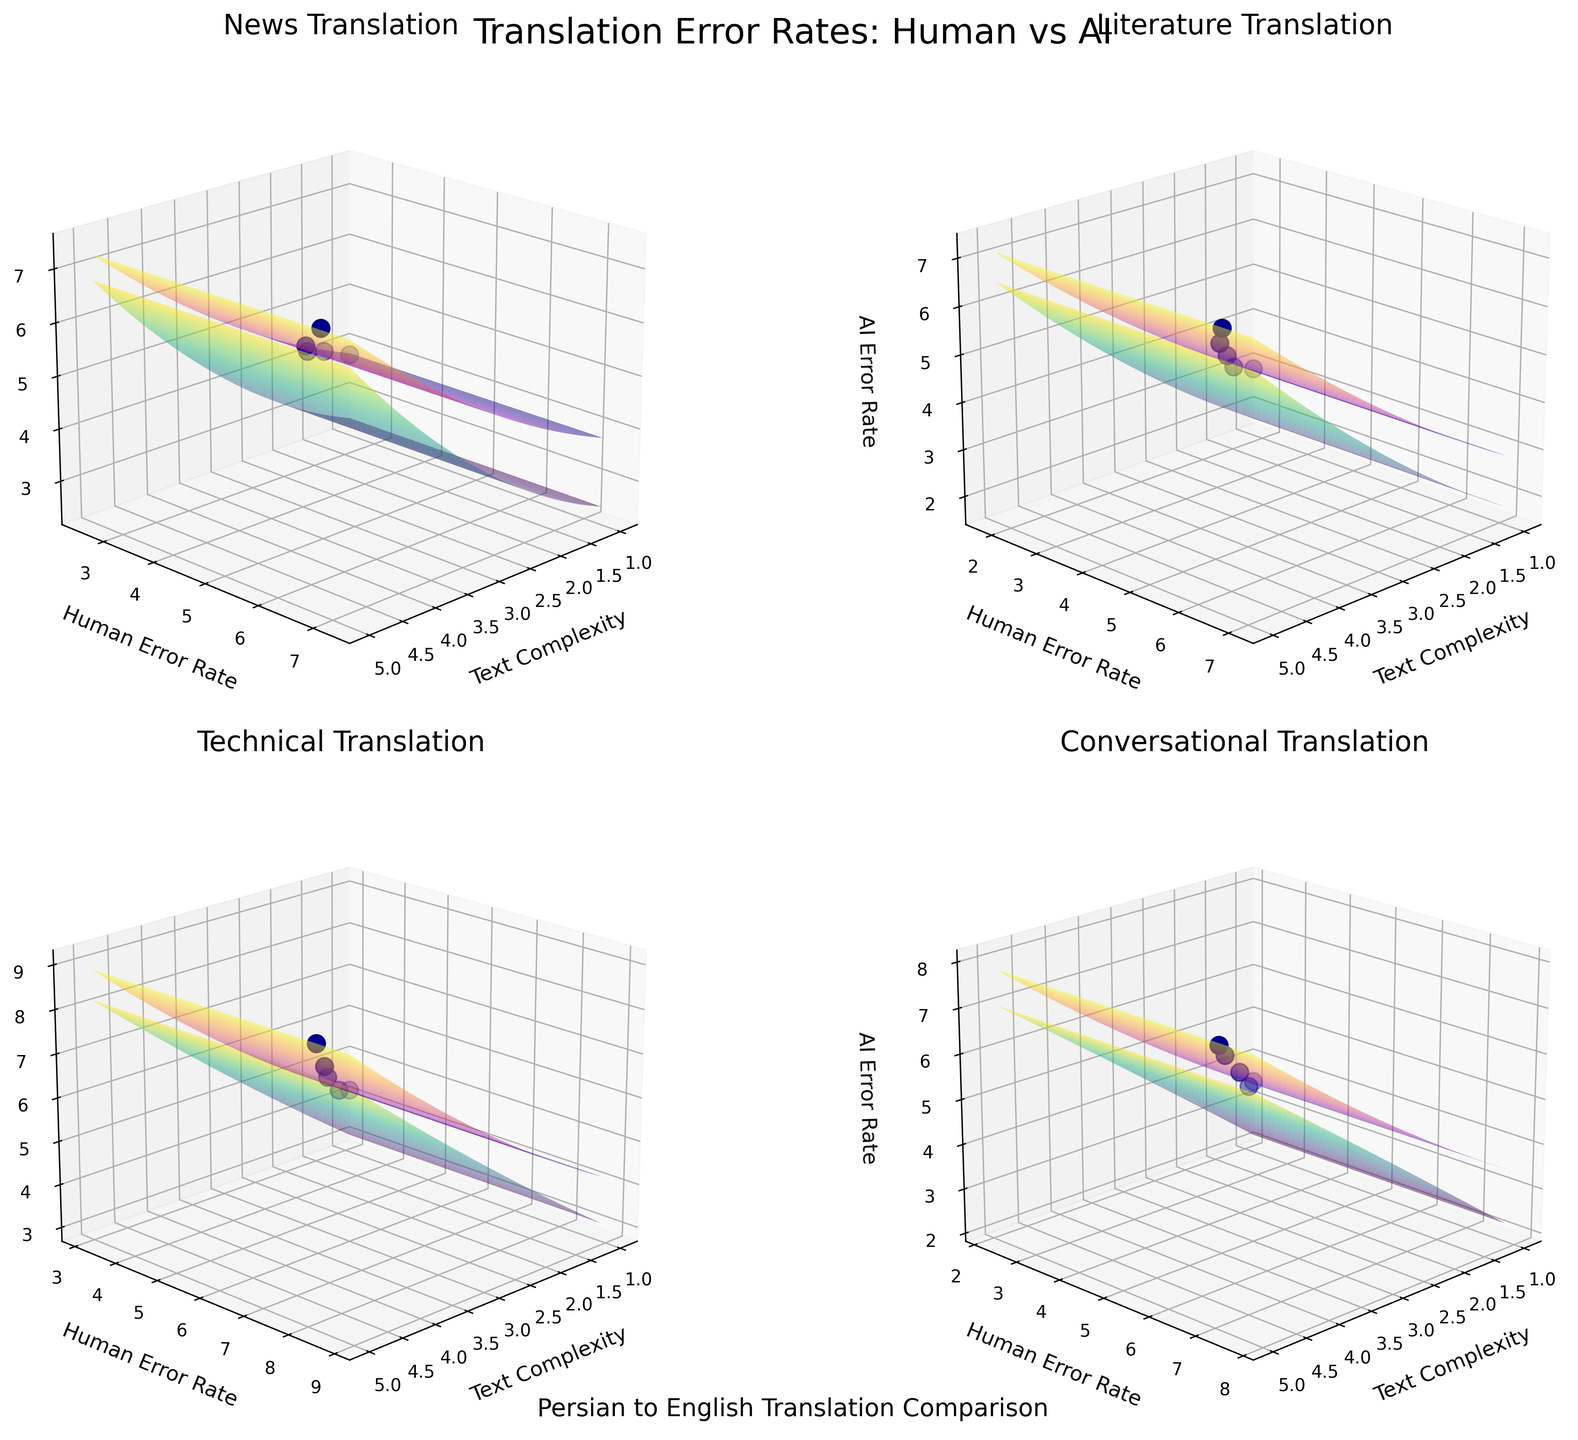Which text type shows the highest AI error rate at text complexity 5? To determine this, we look at the AI error rate at text complexity 5 for each text type. The rates are 7.3 (News), 7.1 (Literature), 8.9 (Technical), and 7.8 (Conversational). Therefore, Technical has the highest AI error rate.
Answer: Technical What is the overall trend for Human error rates as text complexity increases in the News category? By observing the trend surface and scatter points for News, we see that the human error rate increases as text complexity increases, indicating a positive correlation.
Answer: Increases How does the AI error rate for Conversational texts compare to the Human error rate at text complexity 3? For Conversational texts at text complexity 3, the human error rate is 4.7, while the AI error rate is 5.5. Thus, the AI error rate is higher.
Answer: AI error rate is higher What is the difference between Human and AI error rates for Technical texts at text complexity 1? Checking the values for Technical texts at text complexity 1, the human rate is 3.1 and the AI rate is 4.2. The difference is 4.2 - 3.1 = 1.1.
Answer: 1.1 Which text type shows the smallest gap between Human and AI error rates at text complexity 4? Examining each text type at text complexity 4: News (0.8), Literature (0.8), Technical (0.6), Conversational (0.9). The smallest gap is in Technical.
Answer: Technical What is the median human error rate for Literature texts? The human error rates for Literature texts are 1.8, 2.7, 3.9, 5.1, and 6.5. The median is the middle value, which is 3.9 in this dataset.
Answer: 3.9 Which has a steeper slope from text complexity 2 to 3: Human or AI error rate in News? Comparing the increase from text complexity 2 to 3: Human (4.1 - 3.2 = 0.9) and AI (5.2 - 4.5 = 0.7). Thus, the Human error rate has a steeper slope.
Answer: Human For which text type does the gap between Human and AI error rates consistently increase with text complexity? Observing trends, the gap increases consistently in all text types, but more noticeably in Technical where the gap steadily widens as text complexity increases.
Answer: Technical At text complexity 5, which text type shows the highest Human error rate? Observing the values at text complexity 5: News (6.8), Literature (6.5), Technical (8.2), Conversational (7.1). Technical has the highest human error rate.
Answer: Technical 